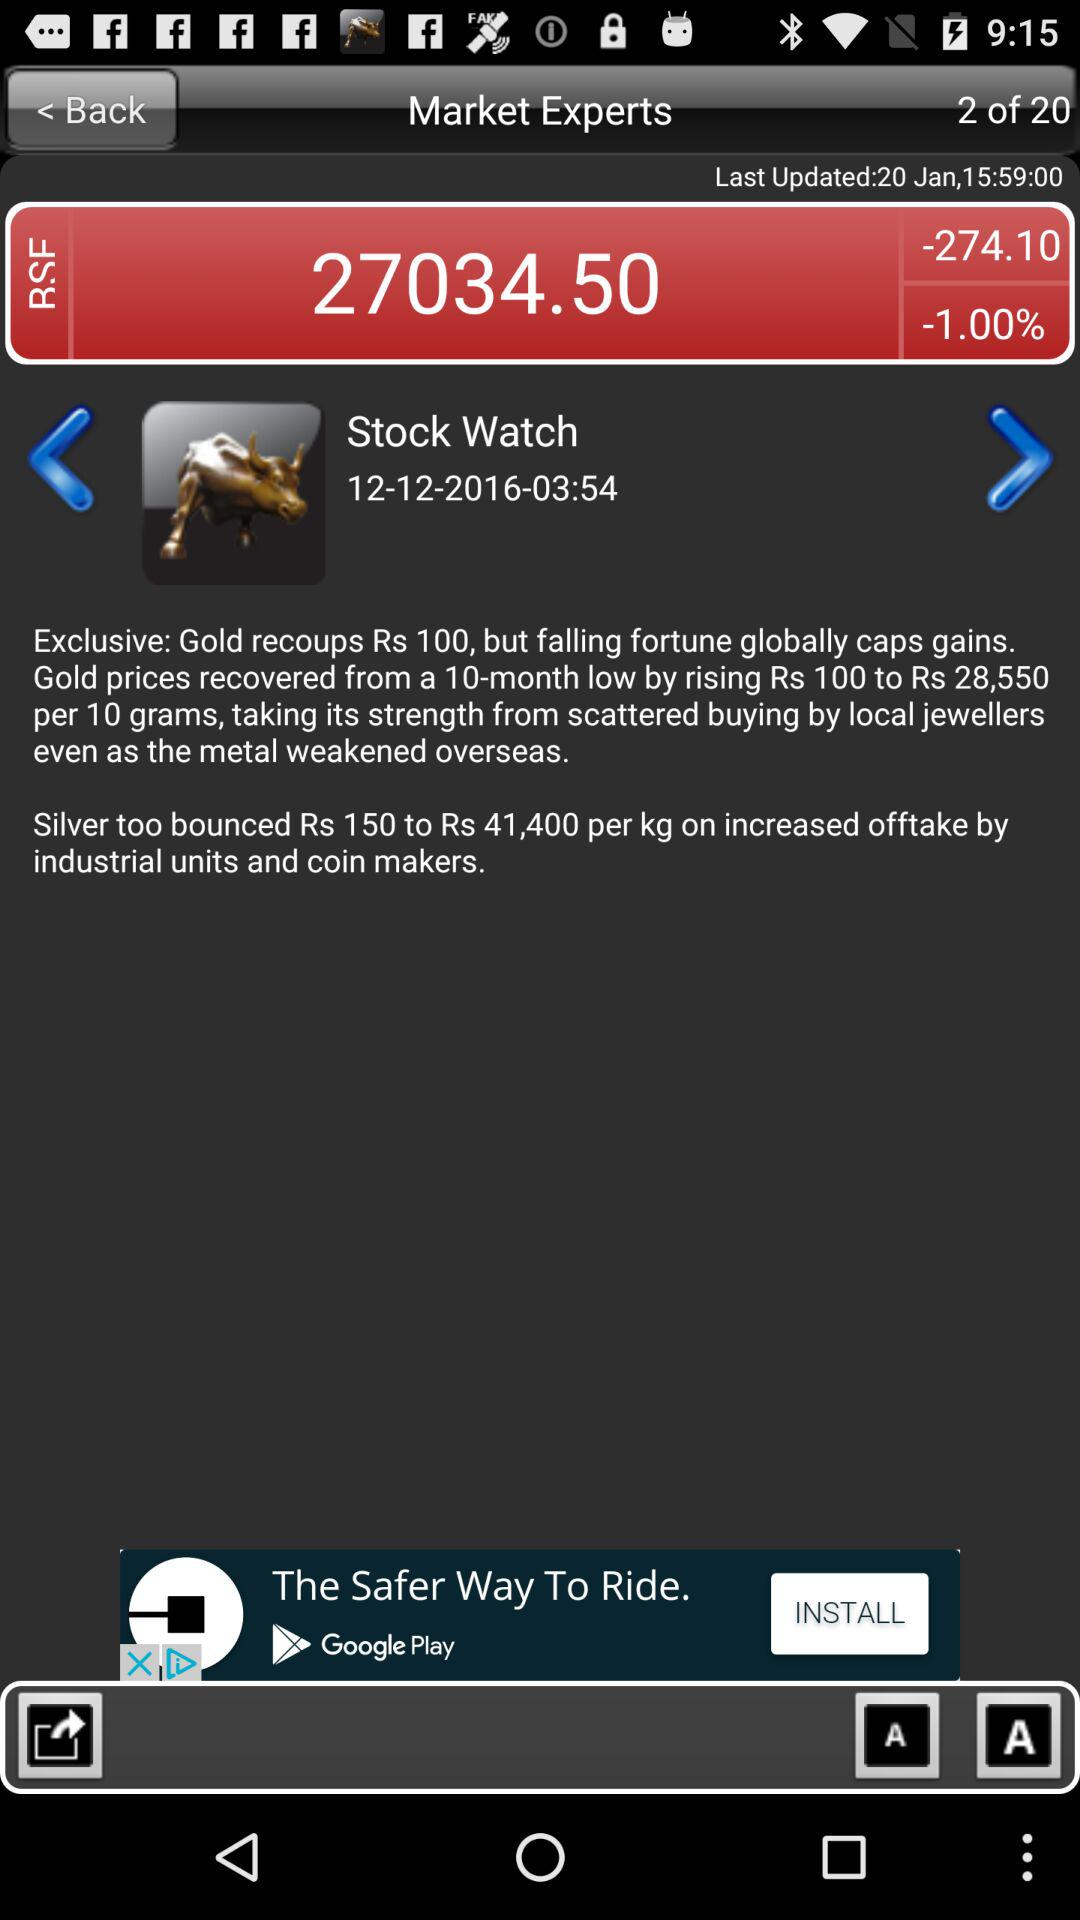What is the time of the last update? The time is 15:59. 